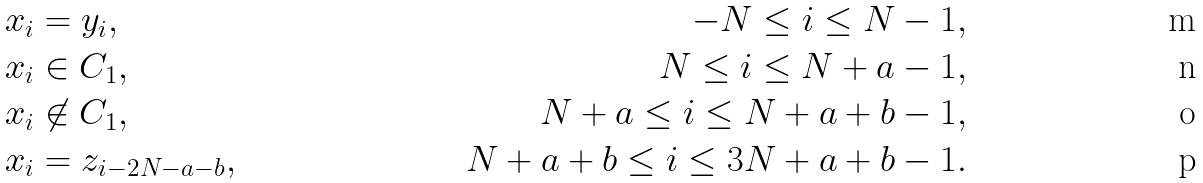<formula> <loc_0><loc_0><loc_500><loc_500>x _ { i } & = y _ { i } , & - N \leq i \leq N - 1 , \\ x _ { i } & \in C _ { 1 } , & N \leq i \leq N + a - 1 , \\ x _ { i } & \not \in C _ { 1 } , & N + a \leq i \leq N + a + b - 1 , \\ x _ { i } & = z _ { i - 2 N - a - b } , & N + a + b \leq i \leq 3 N + a + b - 1 .</formula> 